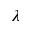Convert formula to latex. <formula><loc_0><loc_0><loc_500><loc_500>\lambda</formula> 